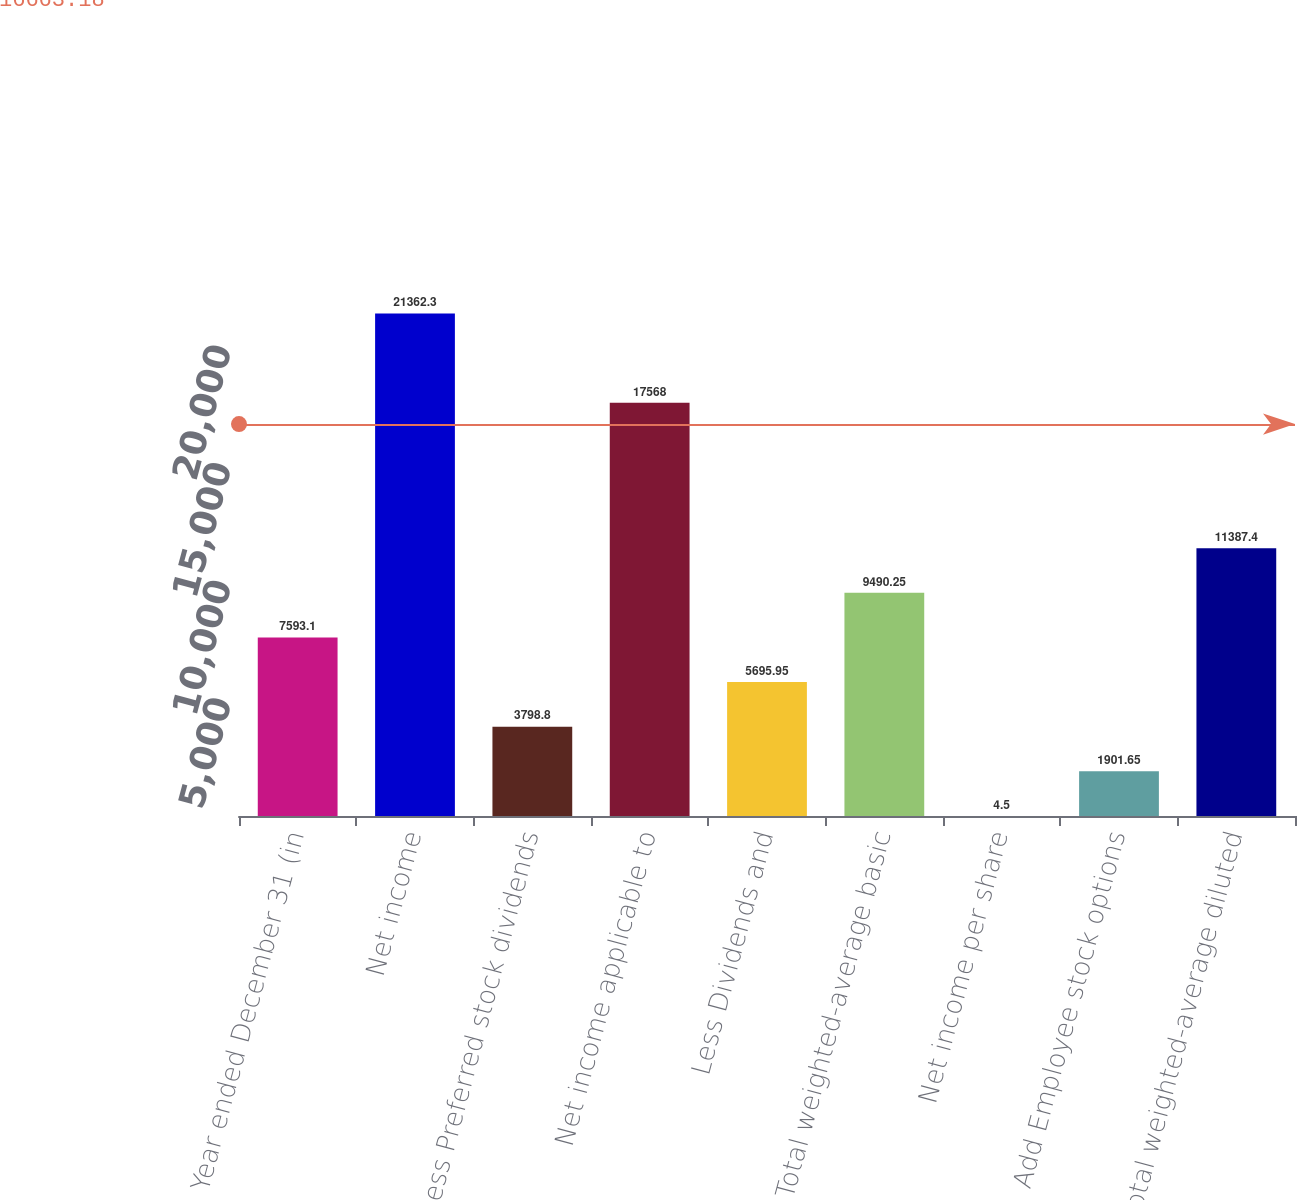Convert chart to OTSL. <chart><loc_0><loc_0><loc_500><loc_500><bar_chart><fcel>Year ended December 31 (in<fcel>Net income<fcel>Less Preferred stock dividends<fcel>Net income applicable to<fcel>Less Dividends and<fcel>Total weighted-average basic<fcel>Net income per share<fcel>Add Employee stock options<fcel>Total weighted-average diluted<nl><fcel>7593.1<fcel>21362.3<fcel>3798.8<fcel>17568<fcel>5695.95<fcel>9490.25<fcel>4.5<fcel>1901.65<fcel>11387.4<nl></chart> 